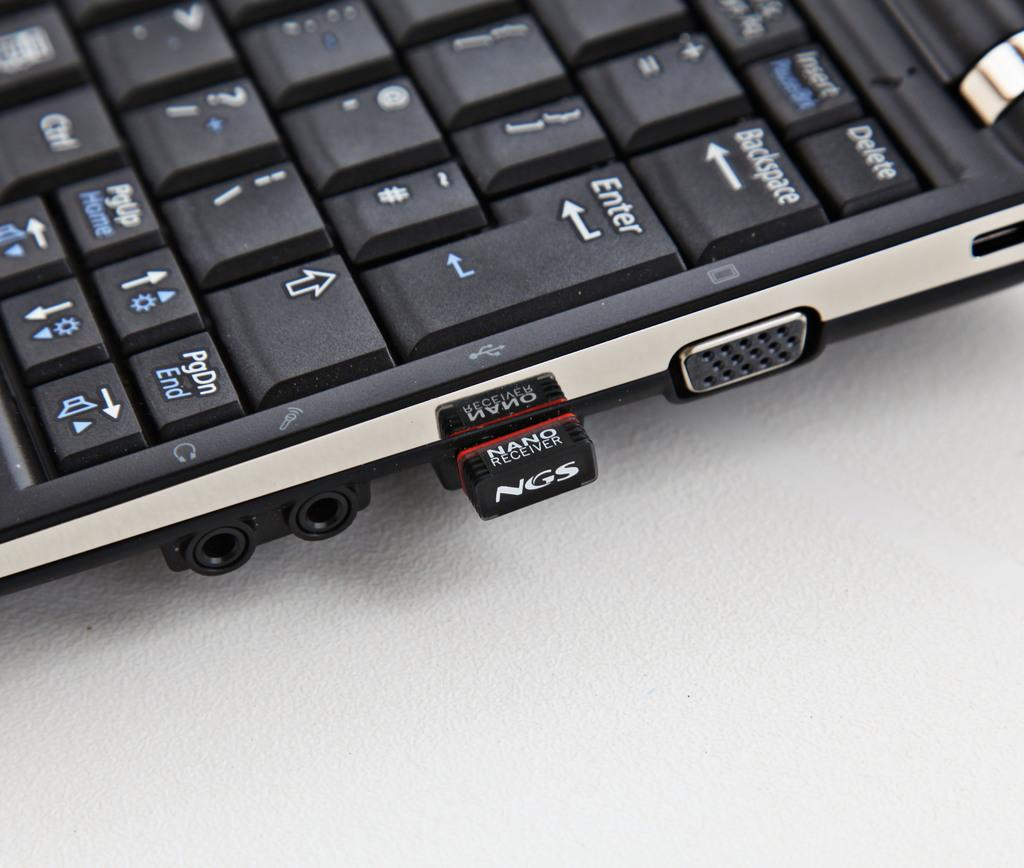<image>
Relay a brief, clear account of the picture shown. A small NGS nano receiver is plugged into the side of a laptop computer. 